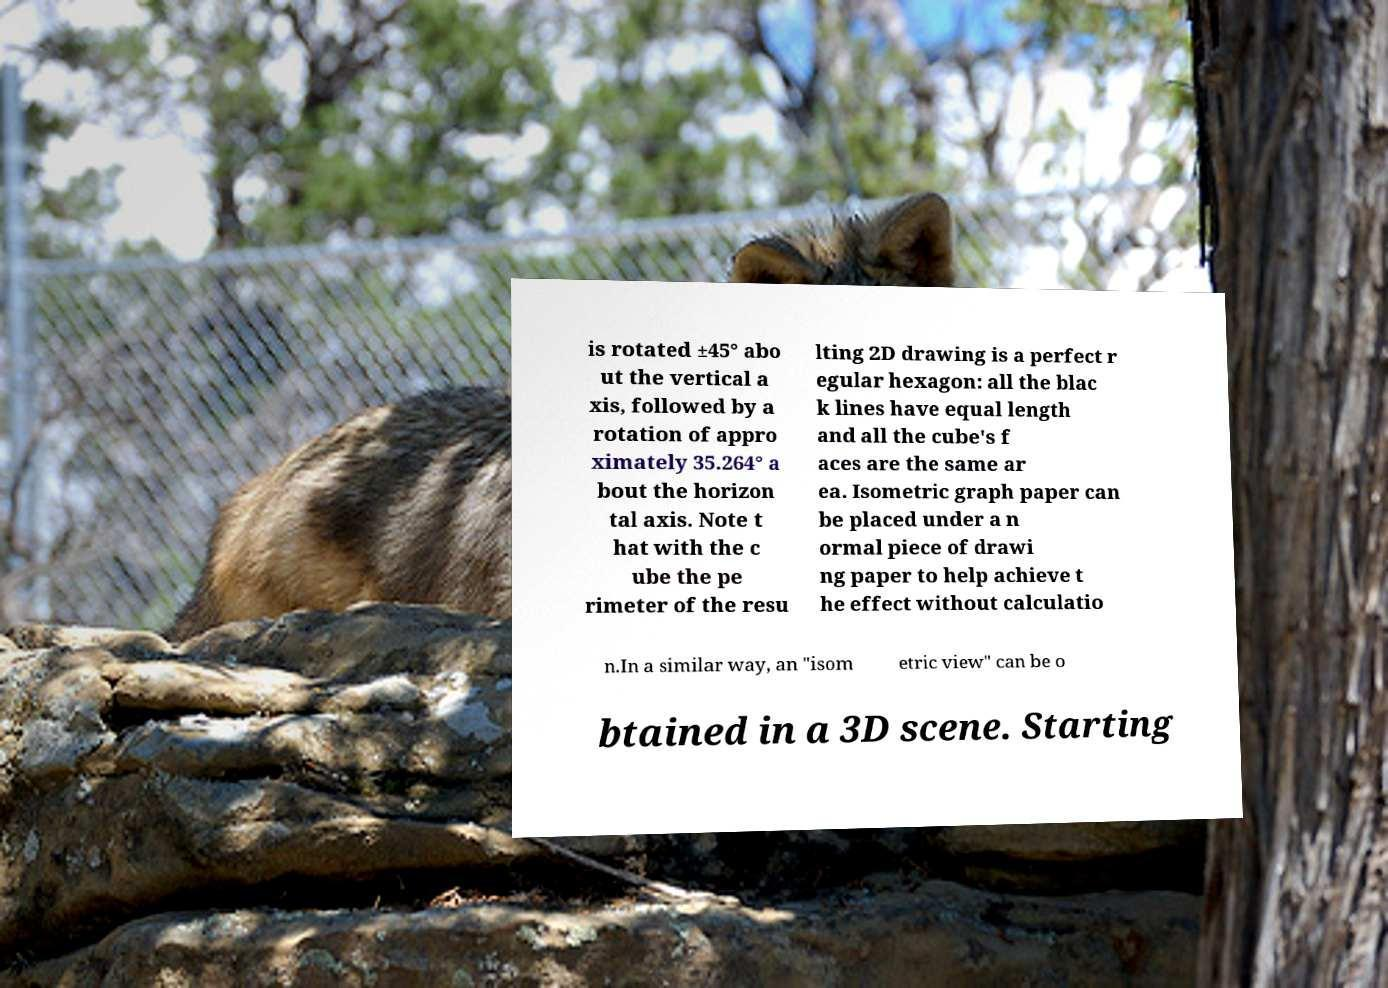Could you extract and type out the text from this image? is rotated ±45° abo ut the vertical a xis, followed by a rotation of appro ximately 35.264° a bout the horizon tal axis. Note t hat with the c ube the pe rimeter of the resu lting 2D drawing is a perfect r egular hexagon: all the blac k lines have equal length and all the cube's f aces are the same ar ea. Isometric graph paper can be placed under a n ormal piece of drawi ng paper to help achieve t he effect without calculatio n.In a similar way, an "isom etric view" can be o btained in a 3D scene. Starting 